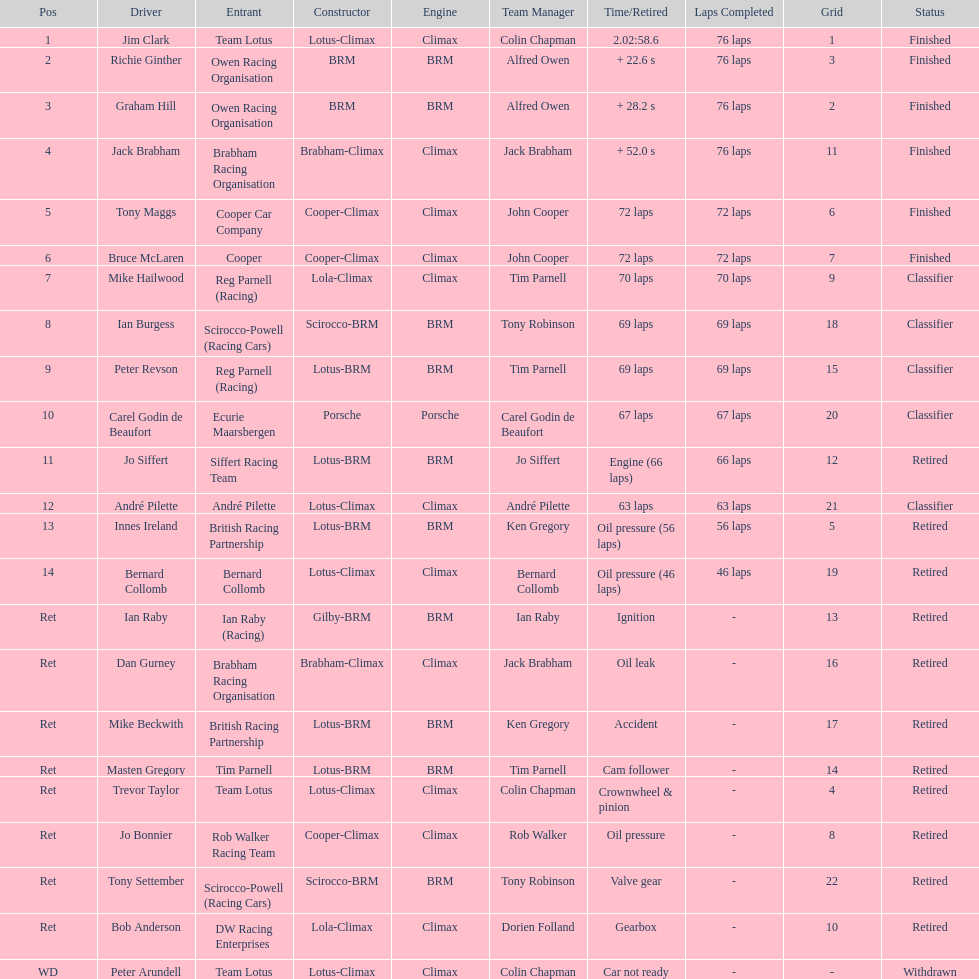Who came in first? Jim Clark. 